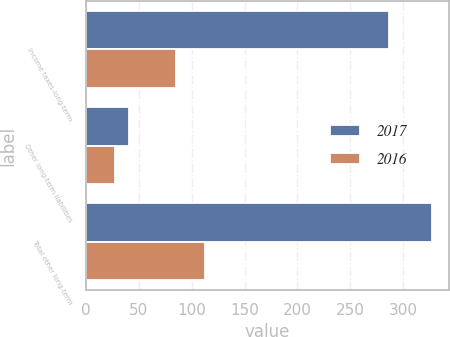Convert chart. <chart><loc_0><loc_0><loc_500><loc_500><stacked_bar_chart><ecel><fcel>Income taxes-long-term<fcel>Other long-term liabilities<fcel>Total other long-term<nl><fcel>2017<fcel>286.8<fcel>40.3<fcel>327.1<nl><fcel>2016<fcel>84.9<fcel>27.7<fcel>112.6<nl></chart> 